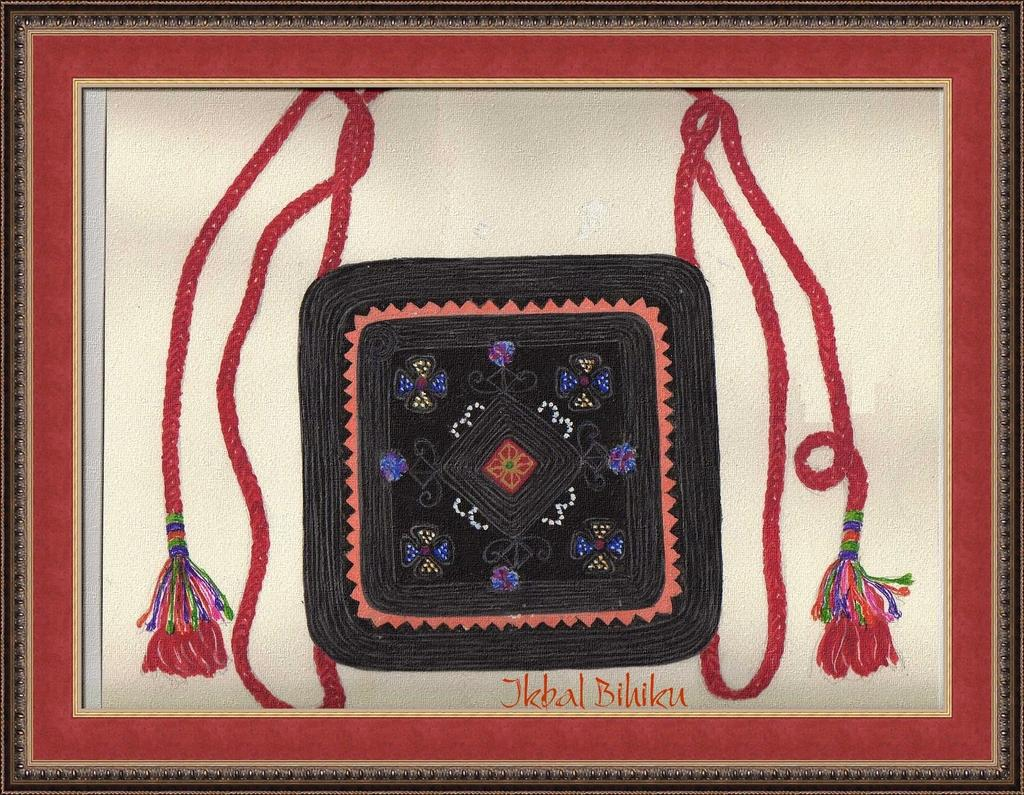<image>
Share a concise interpretation of the image provided. An art display that is signed by the artist Jkbal Bihiku. 